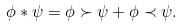<formula> <loc_0><loc_0><loc_500><loc_500>\phi * \psi = \phi \succ \psi + \phi \prec \psi .</formula> 